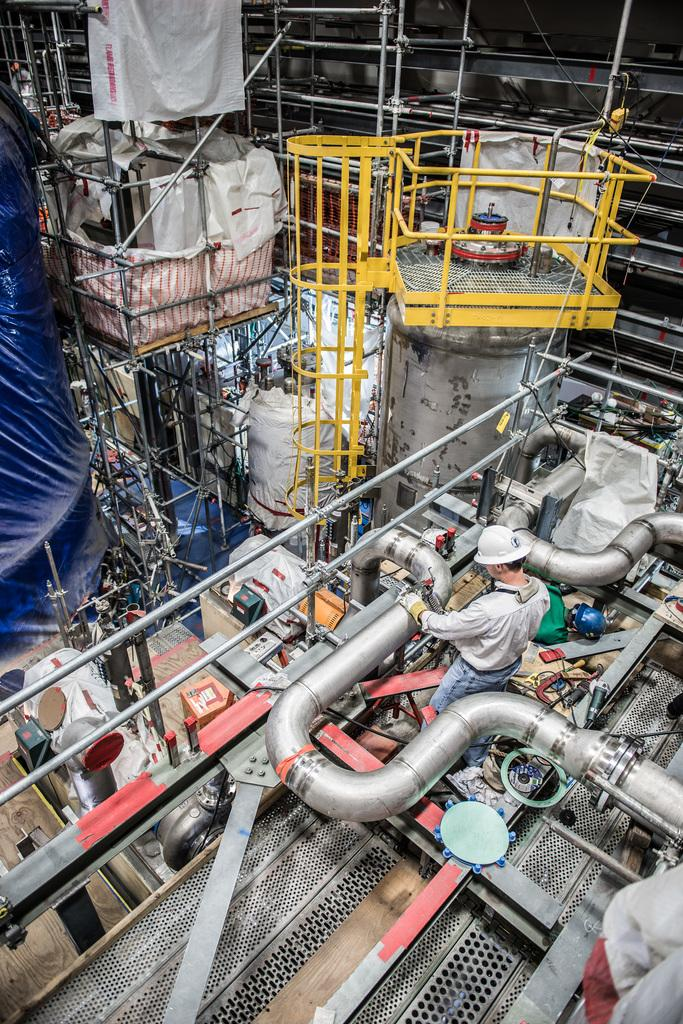Where was the image taken? The image was taken indoors. What is the main feature of the image? There is a huge machinery in the image. What other objects can be seen in the image? There are many pipes, grills, and iron bars in the image. Who is present in the image? A man is standing on the floor in the image. What type of roses can be seen growing on the machinery in the image? There are no roses present in the image; it features a huge machinery, pipes, grills, iron bars, and a man standing on the floor. Can you tell me how many pizzas are being prepared on the grills in the image? There are no pizzas present in the image; it features a huge machinery, pipes, grills, iron bars, and a man standing on the floor. 